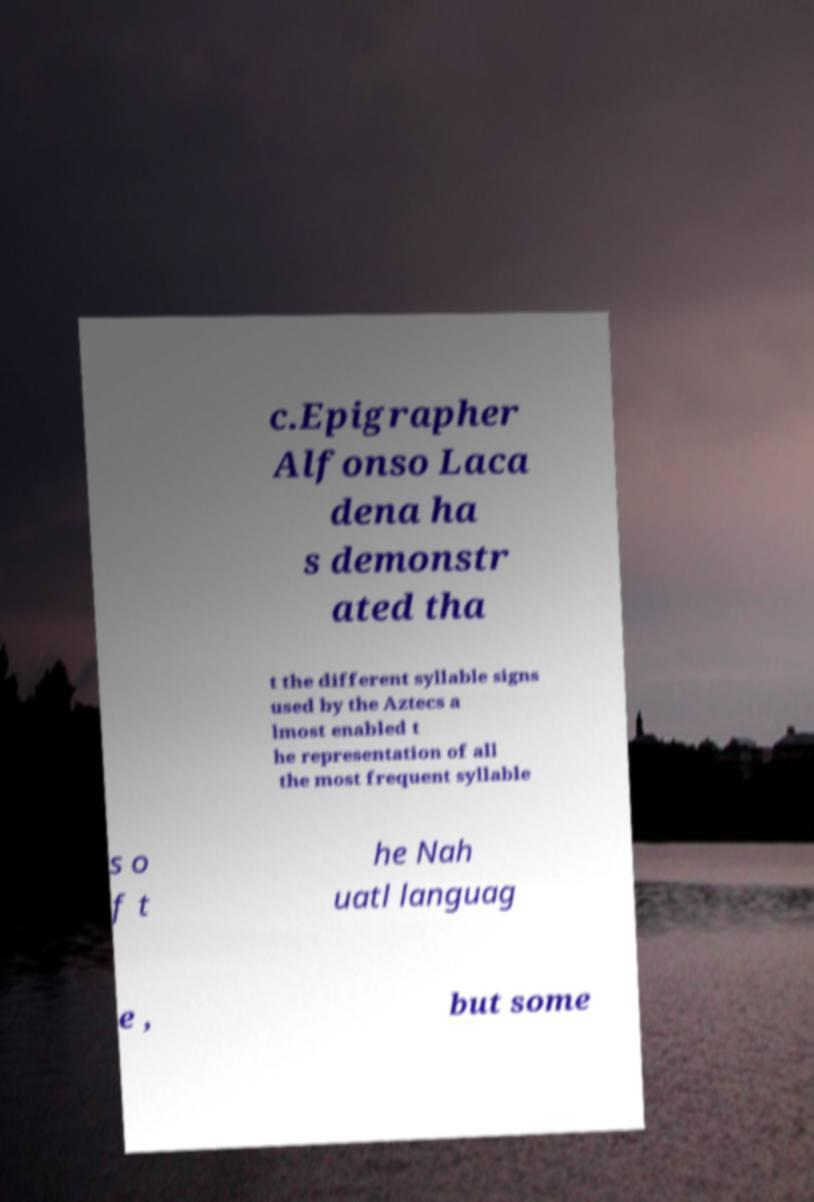I need the written content from this picture converted into text. Can you do that? c.Epigrapher Alfonso Laca dena ha s demonstr ated tha t the different syllable signs used by the Aztecs a lmost enabled t he representation of all the most frequent syllable s o f t he Nah uatl languag e , but some 